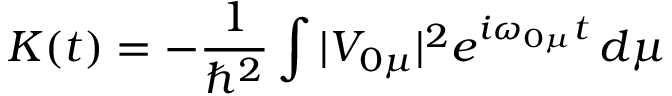<formula> <loc_0><loc_0><loc_500><loc_500>K ( t ) = - \frac { 1 } { \hbar { ^ } { 2 } } \int | V _ { 0 \mu } | ^ { 2 } e ^ { i \omega _ { 0 \mu } t } \, d \mu</formula> 